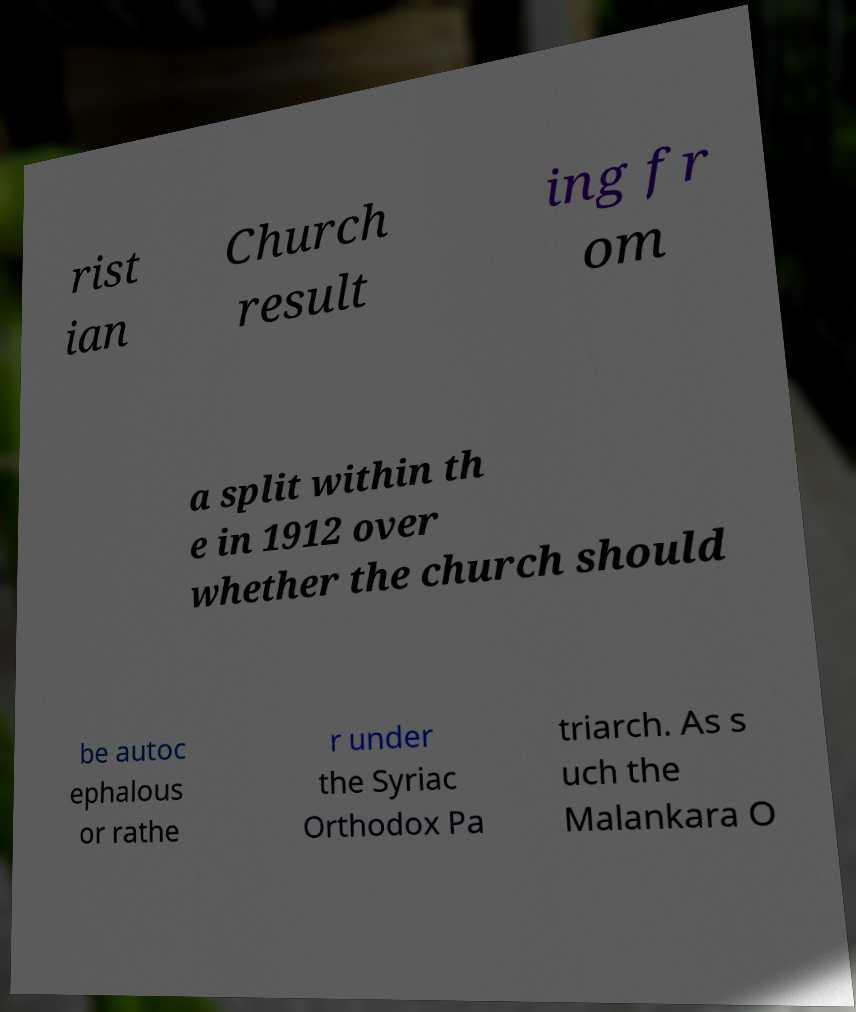I need the written content from this picture converted into text. Can you do that? rist ian Church result ing fr om a split within th e in 1912 over whether the church should be autoc ephalous or rathe r under the Syriac Orthodox Pa triarch. As s uch the Malankara O 